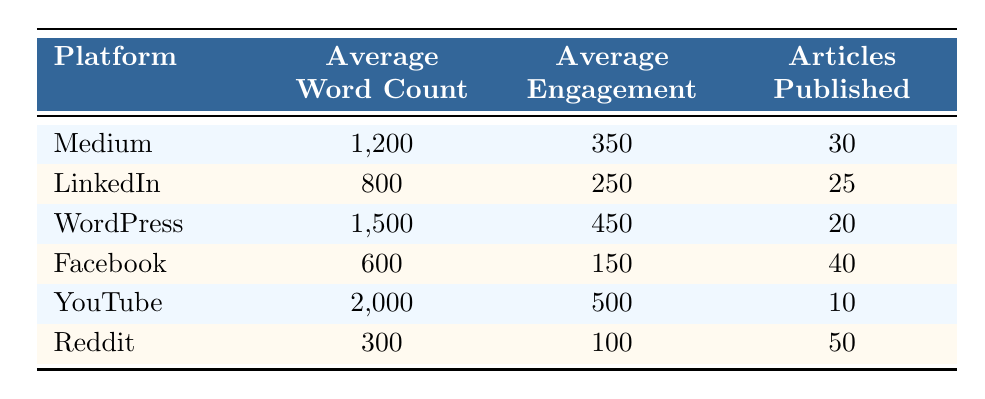What is the average word count for articles published on WordPress? The table indicates that the average word count for articles published on WordPress is listed directly under the "Average Word Count" column for that platform. The value shown is 1,500.
Answer: 1,500 Which platform has the highest average engagement? By comparing the values under the "Average Engagement" column across all platforms, YouTube has the highest engagement at 500.
Answer: YouTube How many articles were published in total across all platforms? To find the total number of articles published, you sum the "Articles Published" values for each platform: 30 + 25 + 20 + 40 + 10 + 50 = 175.
Answer: 175 Is the average engagement for articles published on LinkedIn greater than that on Facebook? The average engagement for LinkedIn is 250, while for Facebook it is 150. Since 250 is greater than 150, the answer is yes.
Answer: Yes What is the difference in average word count between the articles on Medium and those on Reddit? The average word count for Medium is 1,200 and for Reddit is 300. To find the difference, subtract the two: 1,200 - 300 = 900.
Answer: 900 Which platform has the lowest average word count, and what is that value? By examining the "Average Word Count" column, Reddit shows the lowest value at 300.
Answer: Reddit, 300 If you divide the average engagement of YouTube articles by the average engagement of Facebook articles, what is the result? YouTube has an average engagement of 500 and Facebook has 150. Dividing these gives: 500 / 150 = 3.33.
Answer: 3.33 Which platform has published the least number of articles? The "Articles Published" column indicates that YouTube has the fewest articles published, totaling 10.
Answer: YouTube What is the average word count for platforms with more than 30 articles published? The platforms with more than 30 articles published are Medium (1,200) and Facebook (600). The average can be calculated as (1,200 + 600) / 2 = 900.
Answer: 900 